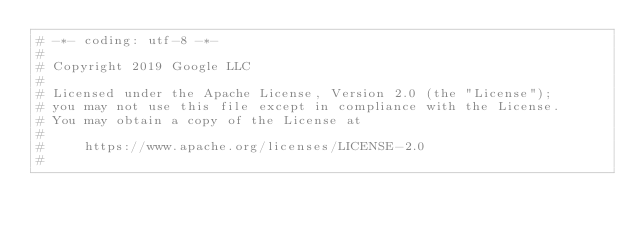<code> <loc_0><loc_0><loc_500><loc_500><_Python_># -*- coding: utf-8 -*-
#
# Copyright 2019 Google LLC
#
# Licensed under the Apache License, Version 2.0 (the "License");
# you may not use this file except in compliance with the License.
# You may obtain a copy of the License at
#
#     https://www.apache.org/licenses/LICENSE-2.0
#</code> 